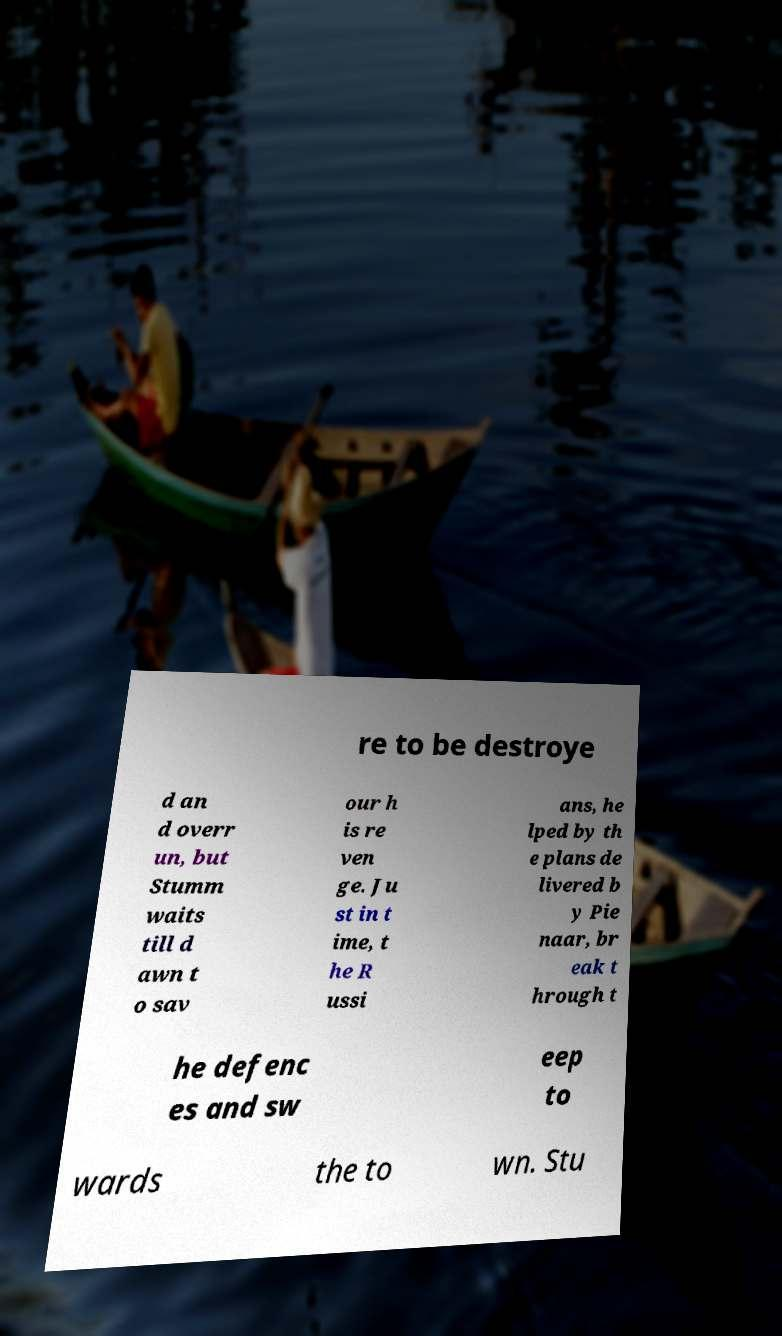Please read and relay the text visible in this image. What does it say? re to be destroye d an d overr un, but Stumm waits till d awn t o sav our h is re ven ge. Ju st in t ime, t he R ussi ans, he lped by th e plans de livered b y Pie naar, br eak t hrough t he defenc es and sw eep to wards the to wn. Stu 